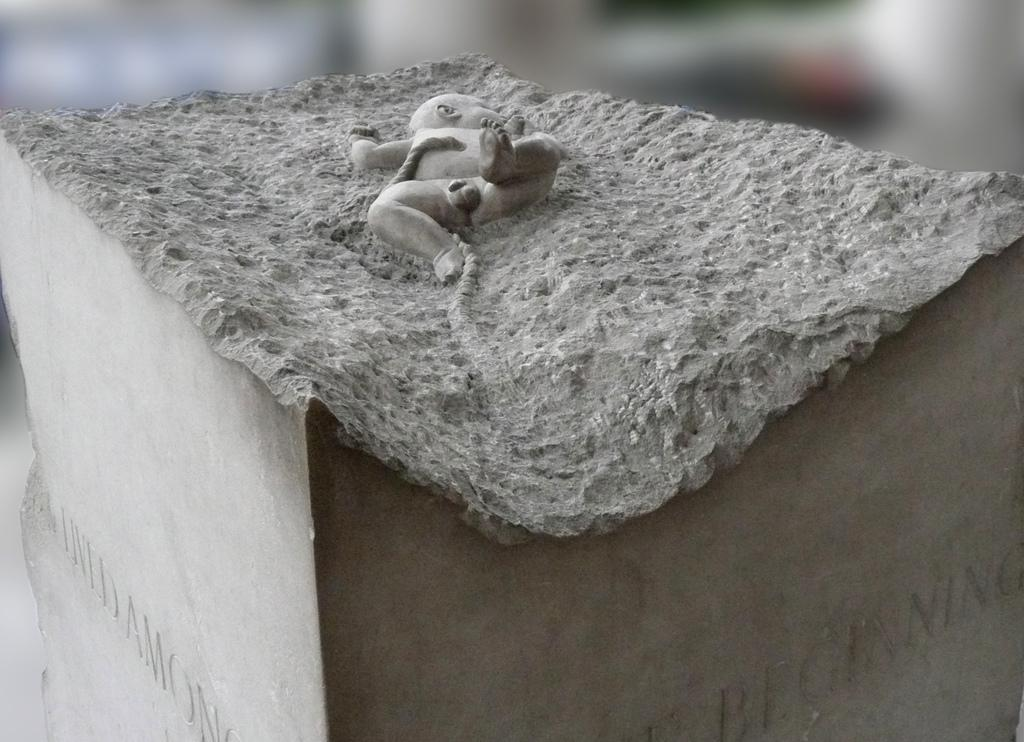What is the main subject of the image? The main subject of the image is a statue of a baby on a pole. Can you describe the background of the image? The background of the image is blurry. How do the giants in the image wash their clothes? There are no giants present in the image, so it is not possible to determine how they might wash their clothes. 